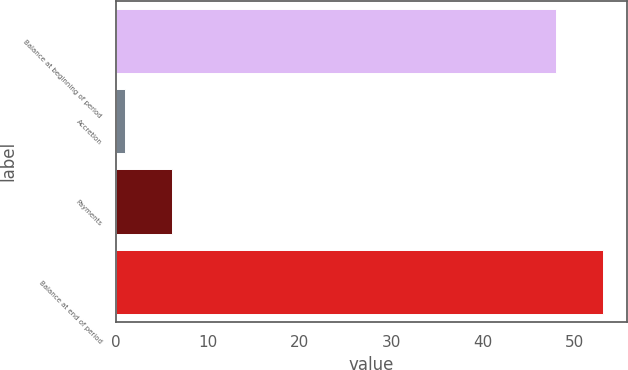<chart> <loc_0><loc_0><loc_500><loc_500><bar_chart><fcel>Balance at beginning of period<fcel>Accretion<fcel>Payments<fcel>Balance at end of period<nl><fcel>48<fcel>1<fcel>6.1<fcel>53.1<nl></chart> 